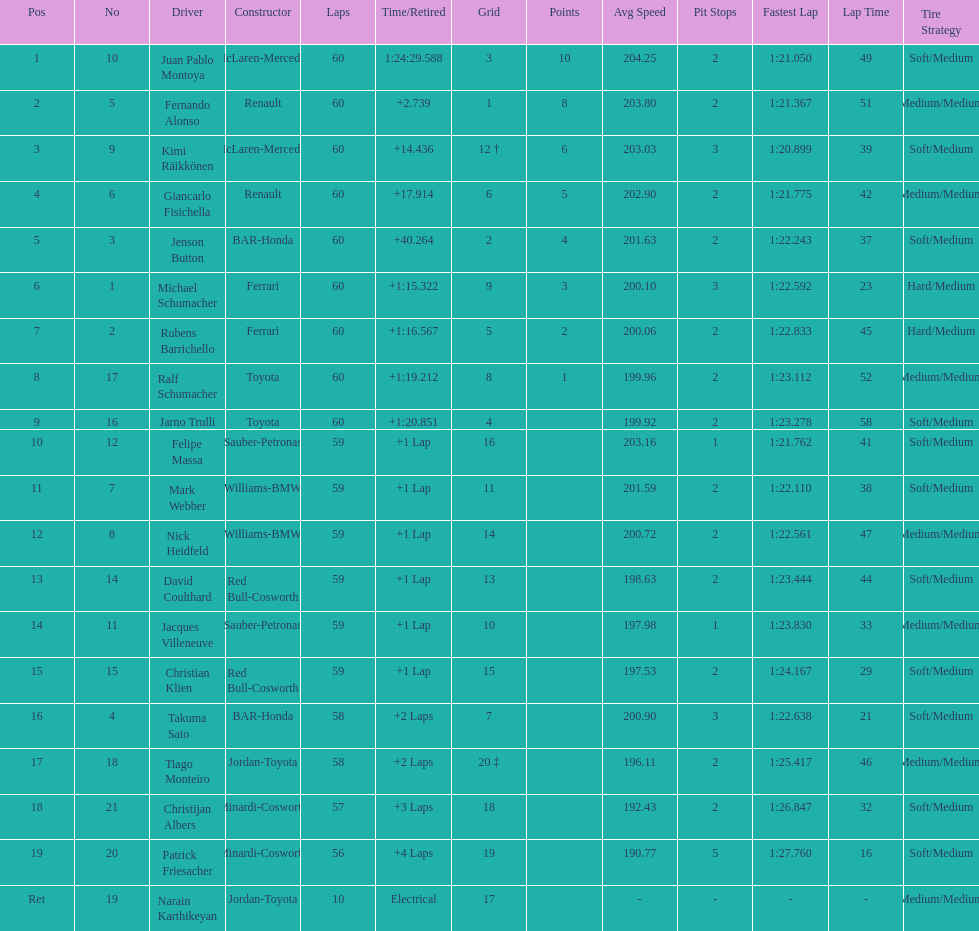How many drivers received points from the race? 8. 